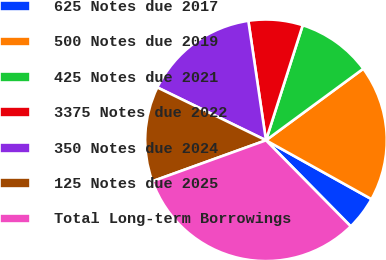Convert chart to OTSL. <chart><loc_0><loc_0><loc_500><loc_500><pie_chart><fcel>625 Notes due 2017<fcel>500 Notes due 2019<fcel>425 Notes due 2021<fcel>3375 Notes due 2022<fcel>350 Notes due 2024<fcel>125 Notes due 2025<fcel>Total Long-term Borrowings<nl><fcel>4.52%<fcel>18.19%<fcel>9.99%<fcel>7.25%<fcel>15.46%<fcel>12.72%<fcel>31.87%<nl></chart> 